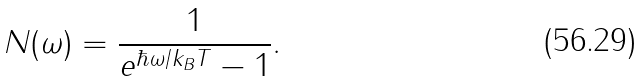Convert formula to latex. <formula><loc_0><loc_0><loc_500><loc_500>N ( \omega ) = \frac { 1 } { { e } ^ { \hbar { \omega } / k _ { B } T } - 1 } .</formula> 